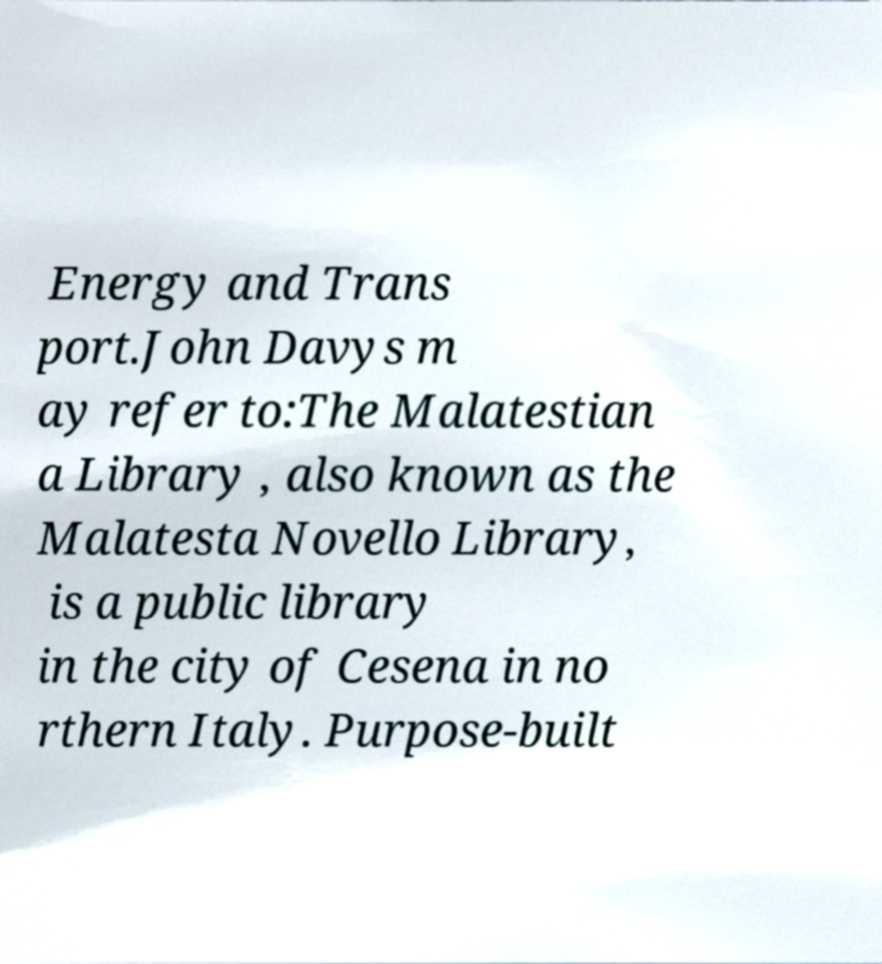Can you read and provide the text displayed in the image?This photo seems to have some interesting text. Can you extract and type it out for me? Energy and Trans port.John Davys m ay refer to:The Malatestian a Library , also known as the Malatesta Novello Library, is a public library in the city of Cesena in no rthern Italy. Purpose-built 